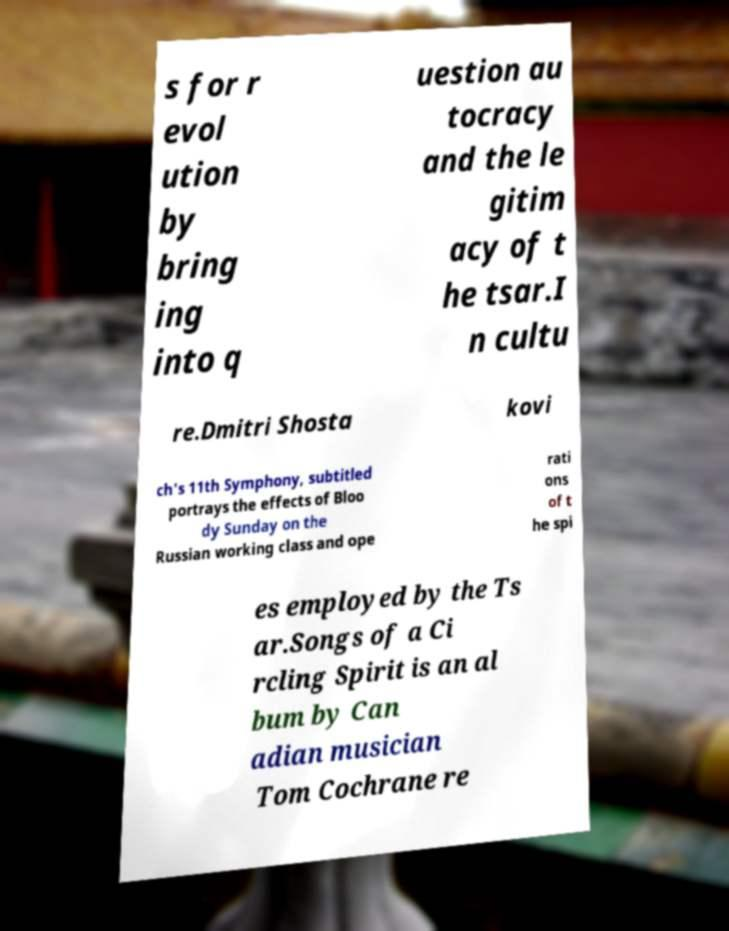What messages or text are displayed in this image? I need them in a readable, typed format. s for r evol ution by bring ing into q uestion au tocracy and the le gitim acy of t he tsar.I n cultu re.Dmitri Shosta kovi ch's 11th Symphony, subtitled portrays the effects of Bloo dy Sunday on the Russian working class and ope rati ons of t he spi es employed by the Ts ar.Songs of a Ci rcling Spirit is an al bum by Can adian musician Tom Cochrane re 